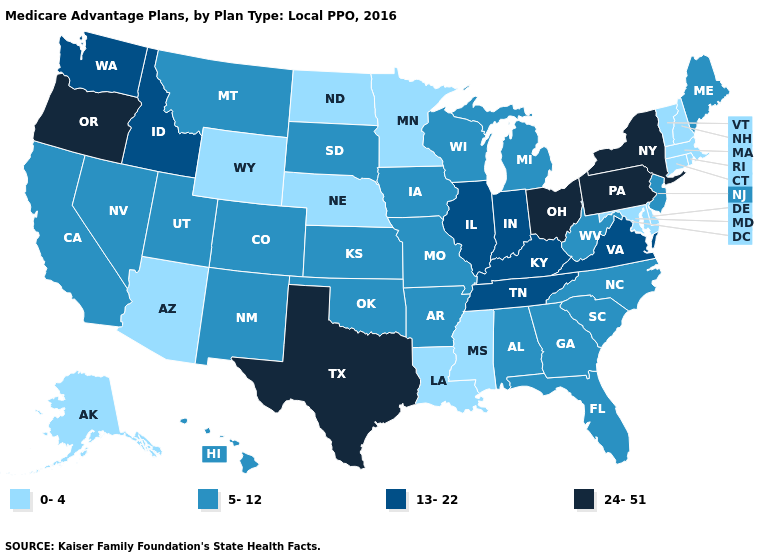What is the lowest value in the USA?
Answer briefly. 0-4. Name the states that have a value in the range 0-4?
Answer briefly. Alaska, Arizona, Connecticut, Delaware, Louisiana, Massachusetts, Maryland, Minnesota, Mississippi, North Dakota, Nebraska, New Hampshire, Rhode Island, Vermont, Wyoming. Name the states that have a value in the range 13-22?
Concise answer only. Idaho, Illinois, Indiana, Kentucky, Tennessee, Virginia, Washington. What is the highest value in the USA?
Short answer required. 24-51. Is the legend a continuous bar?
Short answer required. No. Among the states that border South Dakota , which have the lowest value?
Write a very short answer. Minnesota, North Dakota, Nebraska, Wyoming. What is the value of Iowa?
Give a very brief answer. 5-12. Which states hav the highest value in the MidWest?
Concise answer only. Ohio. Name the states that have a value in the range 24-51?
Be succinct. New York, Ohio, Oregon, Pennsylvania, Texas. Does the map have missing data?
Short answer required. No. Does the map have missing data?
Write a very short answer. No. Is the legend a continuous bar?
Quick response, please. No. Does Texas have a higher value than Illinois?
Be succinct. Yes. Does New Jersey have the same value as Nebraska?
Short answer required. No. 